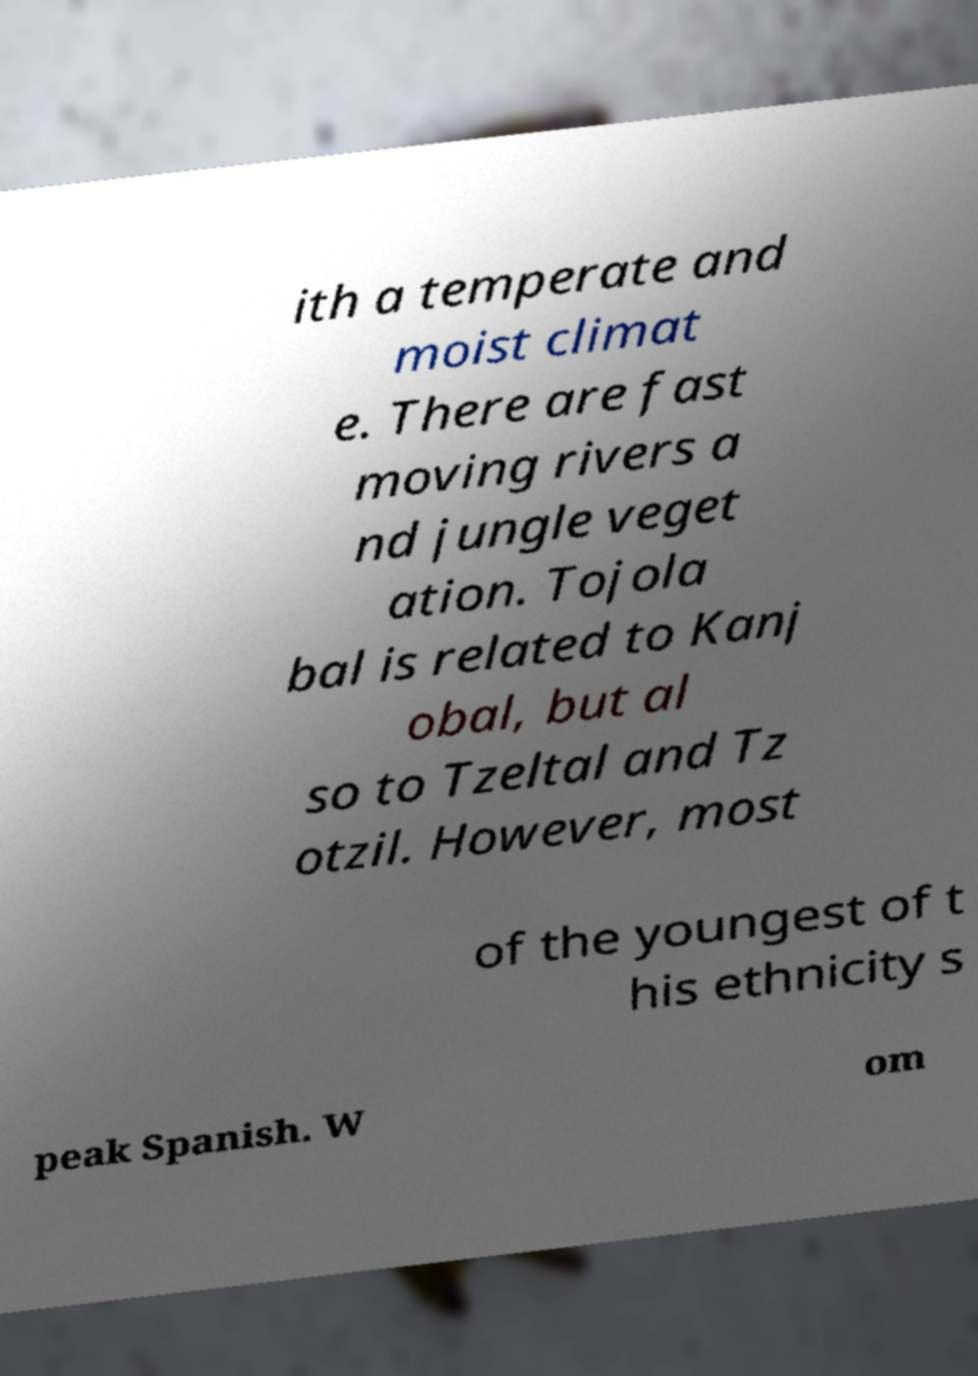There's text embedded in this image that I need extracted. Can you transcribe it verbatim? ith a temperate and moist climat e. There are fast moving rivers a nd jungle veget ation. Tojola bal is related to Kanj obal, but al so to Tzeltal and Tz otzil. However, most of the youngest of t his ethnicity s peak Spanish. W om 